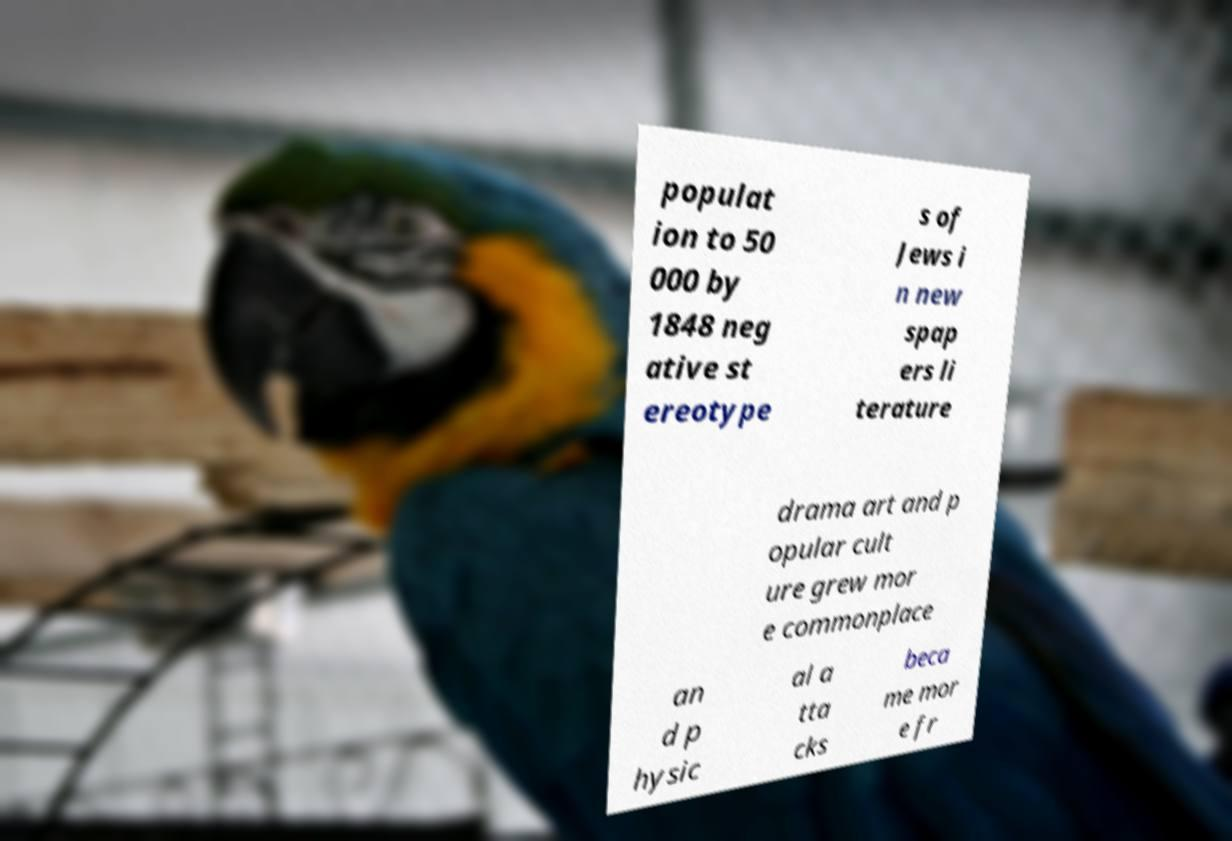Please identify and transcribe the text found in this image. populat ion to 50 000 by 1848 neg ative st ereotype s of Jews i n new spap ers li terature drama art and p opular cult ure grew mor e commonplace an d p hysic al a tta cks beca me mor e fr 